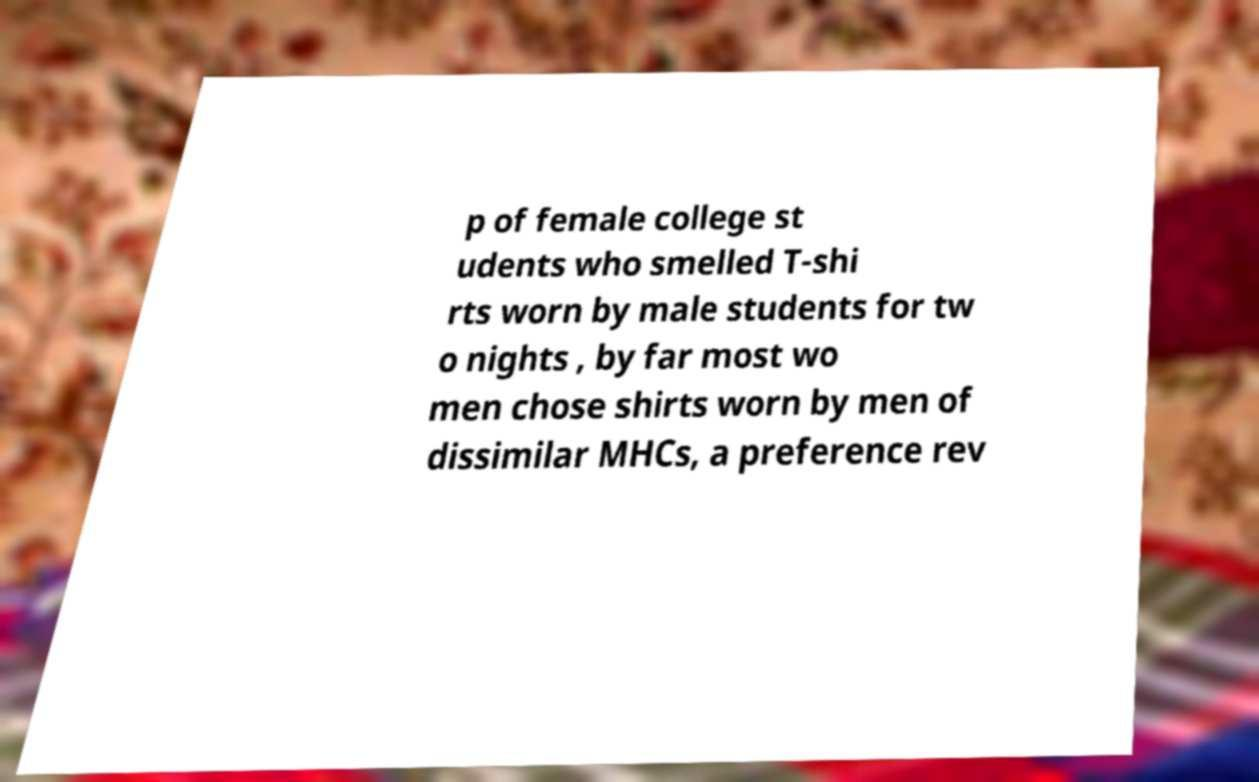Please read and relay the text visible in this image. What does it say? p of female college st udents who smelled T-shi rts worn by male students for tw o nights , by far most wo men chose shirts worn by men of dissimilar MHCs, a preference rev 